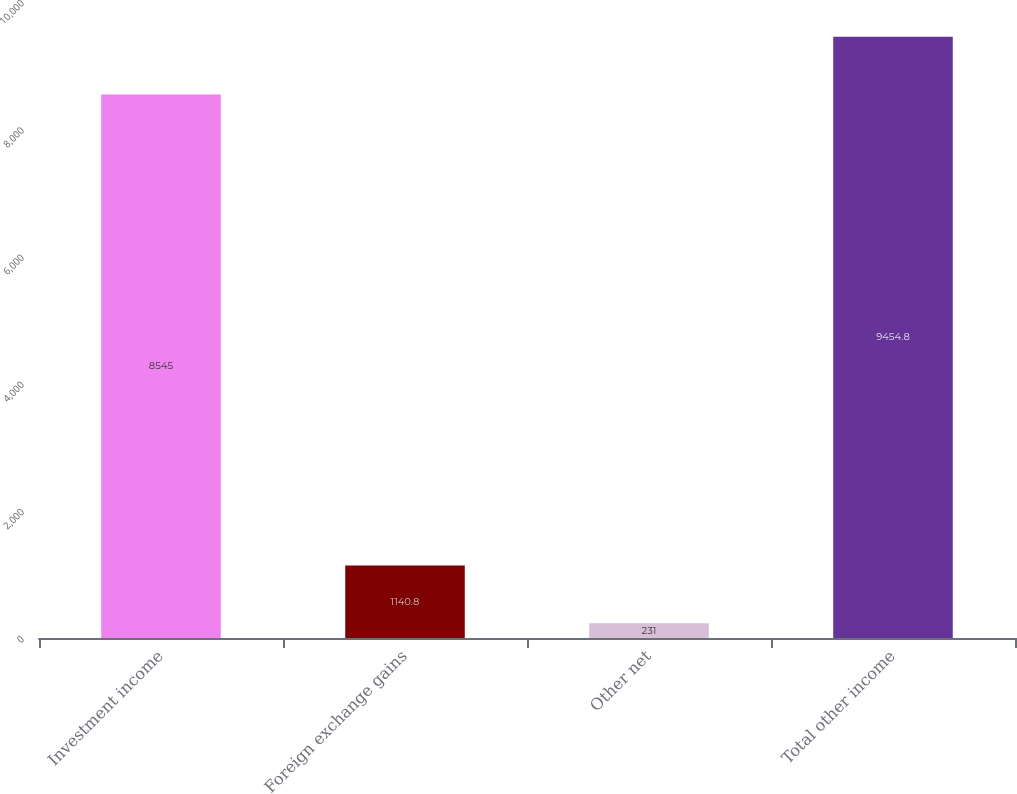<chart> <loc_0><loc_0><loc_500><loc_500><bar_chart><fcel>Investment income<fcel>Foreign exchange gains<fcel>Other net<fcel>Total other income<nl><fcel>8545<fcel>1140.8<fcel>231<fcel>9454.8<nl></chart> 